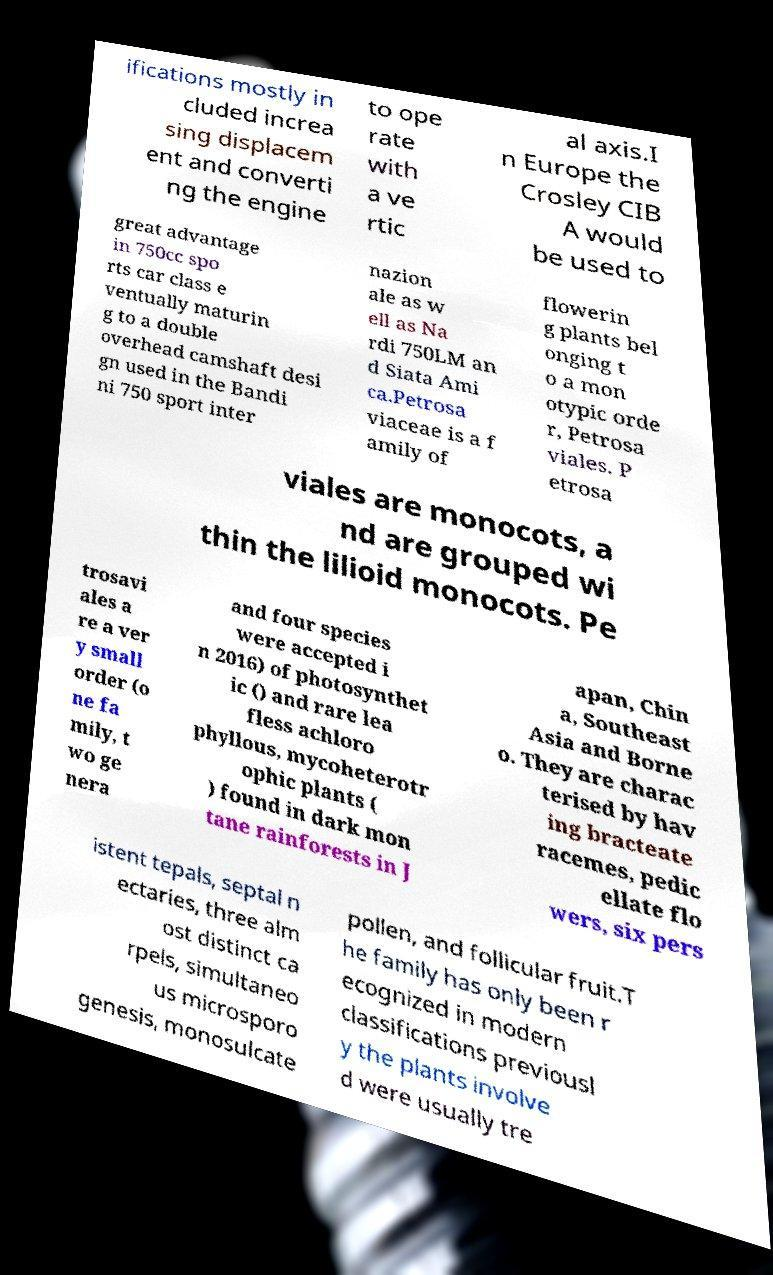Can you read and provide the text displayed in the image?This photo seems to have some interesting text. Can you extract and type it out for me? ifications mostly in cluded increa sing displacem ent and converti ng the engine to ope rate with a ve rtic al axis.I n Europe the Crosley CIB A would be used to great advantage in 750cc spo rts car class e ventually maturin g to a double overhead camshaft desi gn used in the Bandi ni 750 sport inter nazion ale as w ell as Na rdi 750LM an d Siata Ami ca.Petrosa viaceae is a f amily of flowerin g plants bel onging t o a mon otypic orde r, Petrosa viales. P etrosa viales are monocots, a nd are grouped wi thin the lilioid monocots. Pe trosavi ales a re a ver y small order (o ne fa mily, t wo ge nera and four species were accepted i n 2016) of photosynthet ic () and rare lea fless achloro phyllous, mycoheterotr ophic plants ( ) found in dark mon tane rainforests in J apan, Chin a, Southeast Asia and Borne o. They are charac terised by hav ing bracteate racemes, pedic ellate flo wers, six pers istent tepals, septal n ectaries, three alm ost distinct ca rpels, simultaneo us microsporo genesis, monosulcate pollen, and follicular fruit.T he family has only been r ecognized in modern classifications previousl y the plants involve d were usually tre 